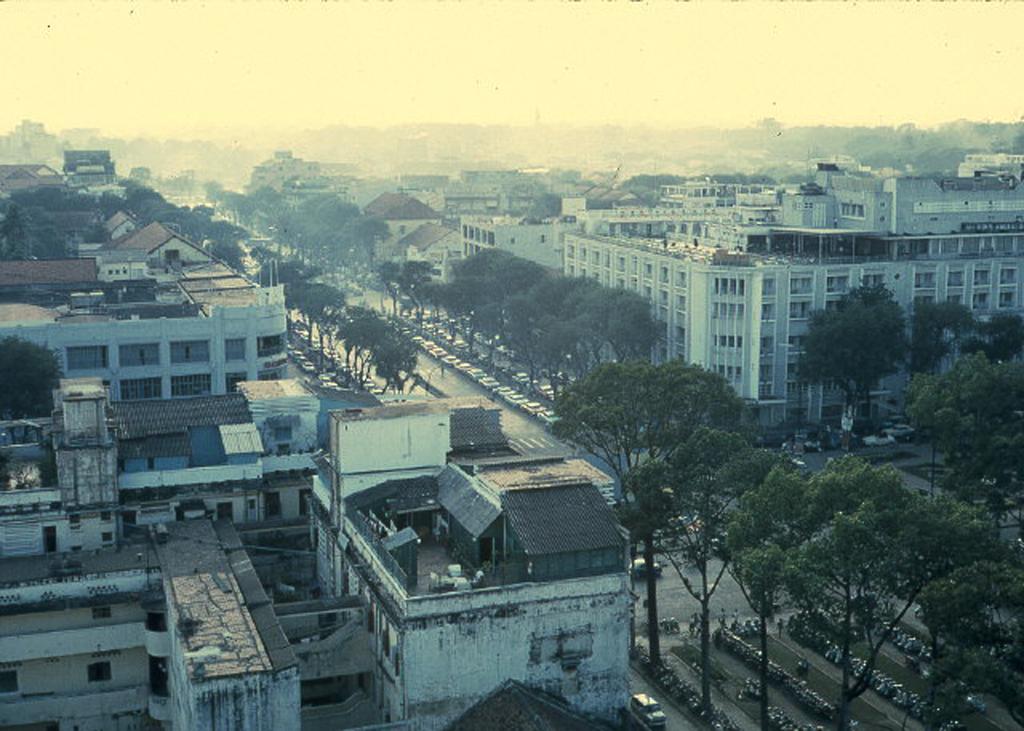Can you describe this image briefly? This is the top view of the city, in this image there are buildings, trees and vehicles, people on the roads. 